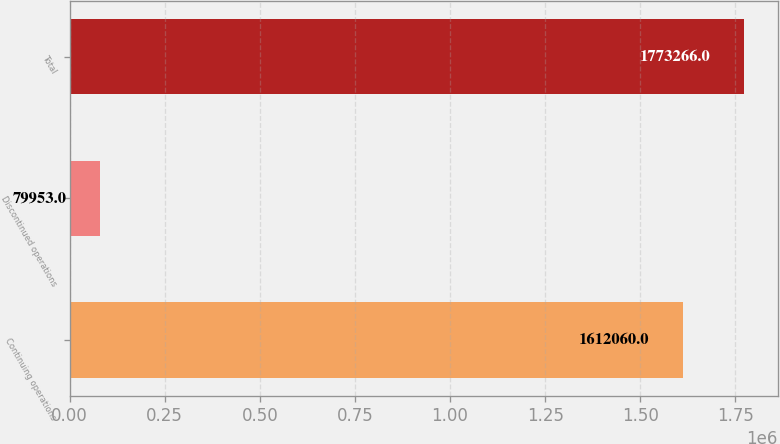Convert chart. <chart><loc_0><loc_0><loc_500><loc_500><bar_chart><fcel>Continuing operations<fcel>Discontinued operations<fcel>Total<nl><fcel>1.61206e+06<fcel>79953<fcel>1.77327e+06<nl></chart> 